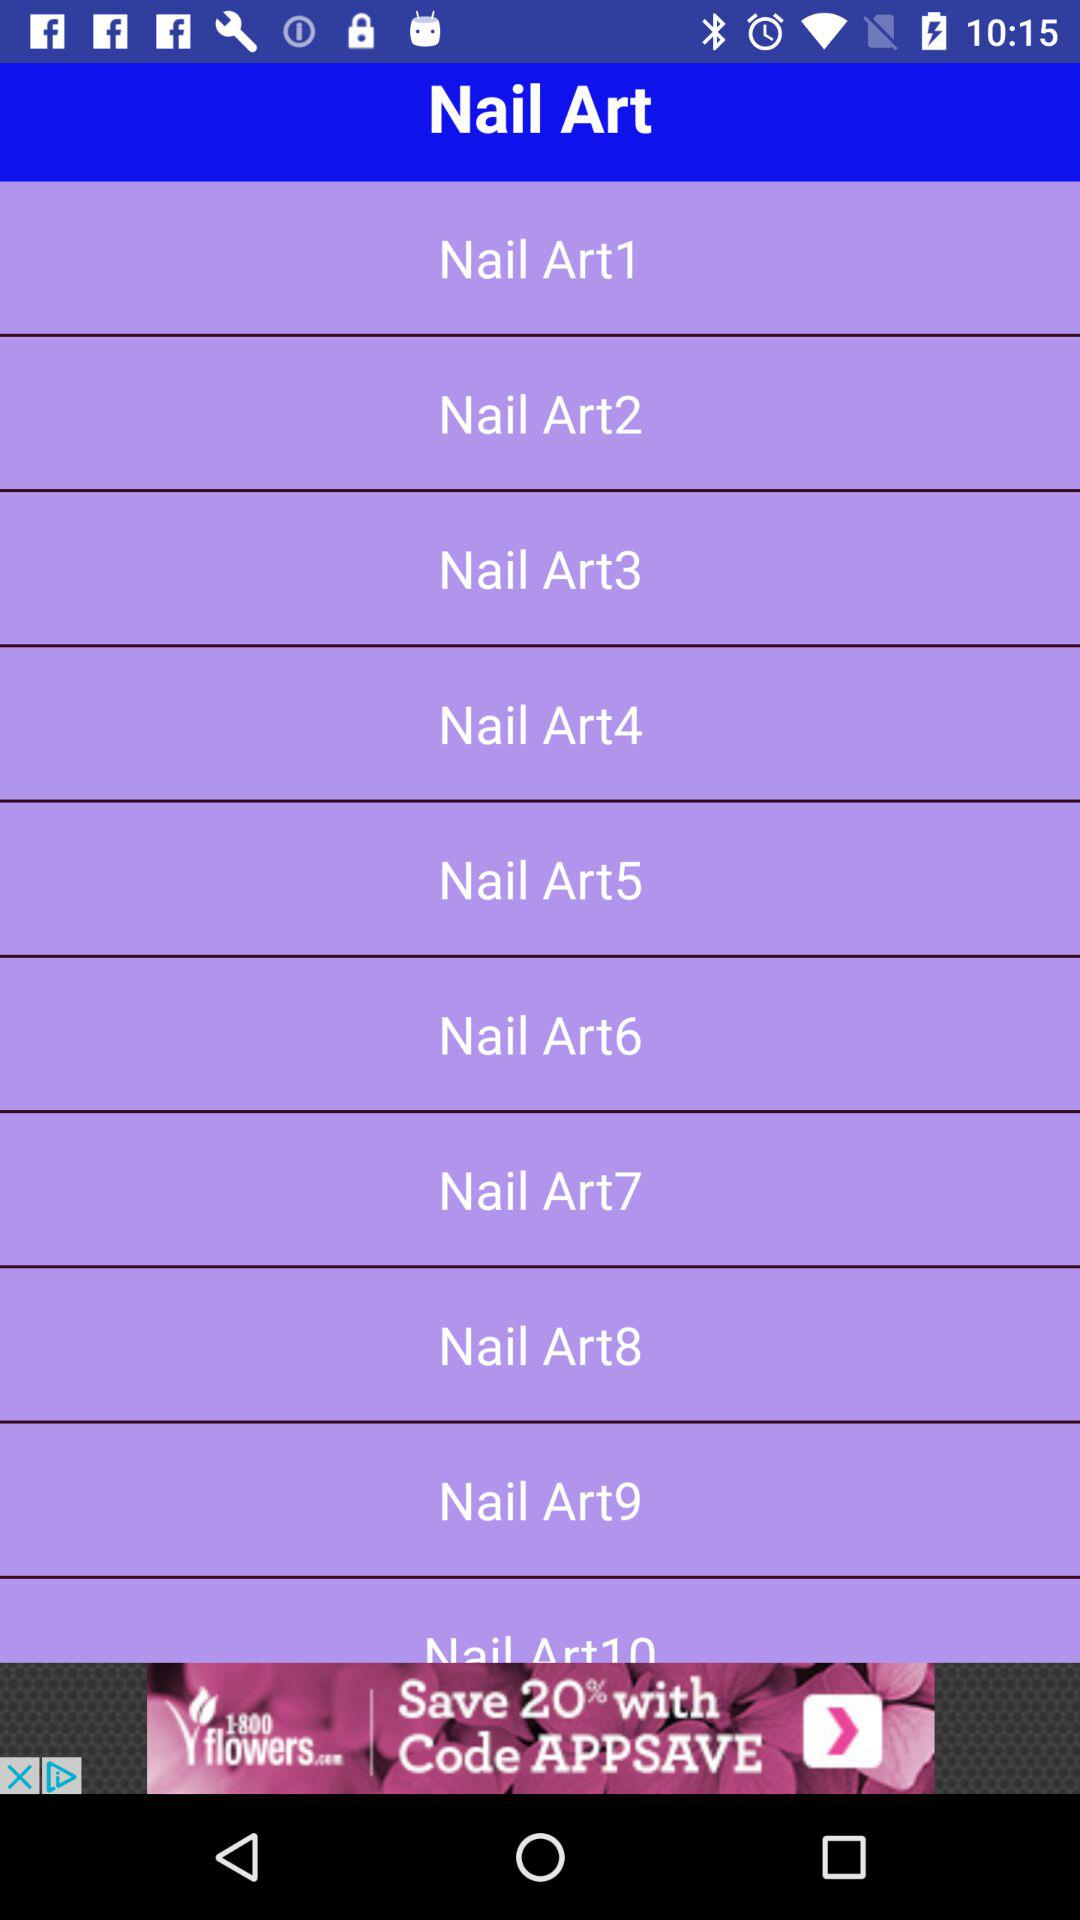Which are the different nail arts? The different nail arts are "Nail Art1", "Nail Art2", "Nail Art3", "Nail Art4", "Nail Art5", "Nail Art6", "Nail Art7", "Nail Art8", "Nail Art9" and "Nail Art10". 